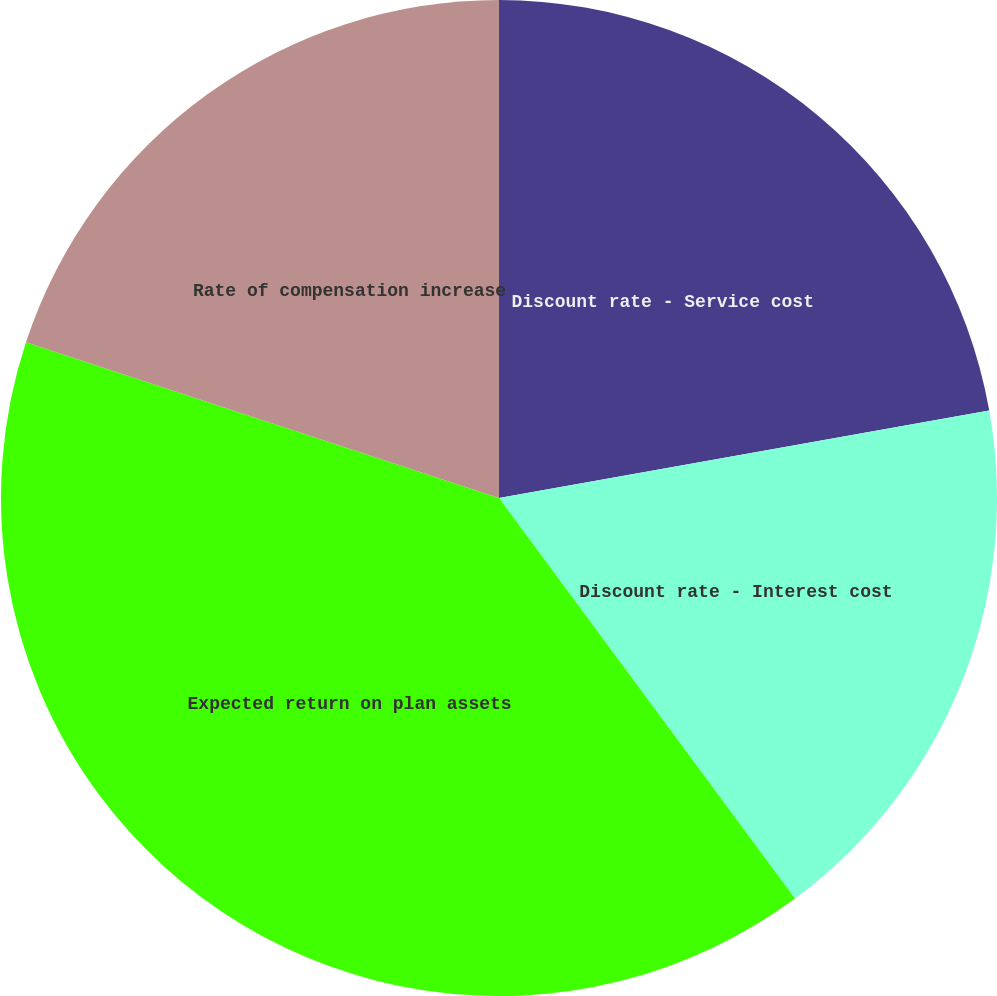Convert chart. <chart><loc_0><loc_0><loc_500><loc_500><pie_chart><fcel>Discount rate - Service cost<fcel>Discount rate - Interest cost<fcel>Expected return on plan assets<fcel>Rate of compensation increase<nl><fcel>22.19%<fcel>17.68%<fcel>40.19%<fcel>19.94%<nl></chart> 